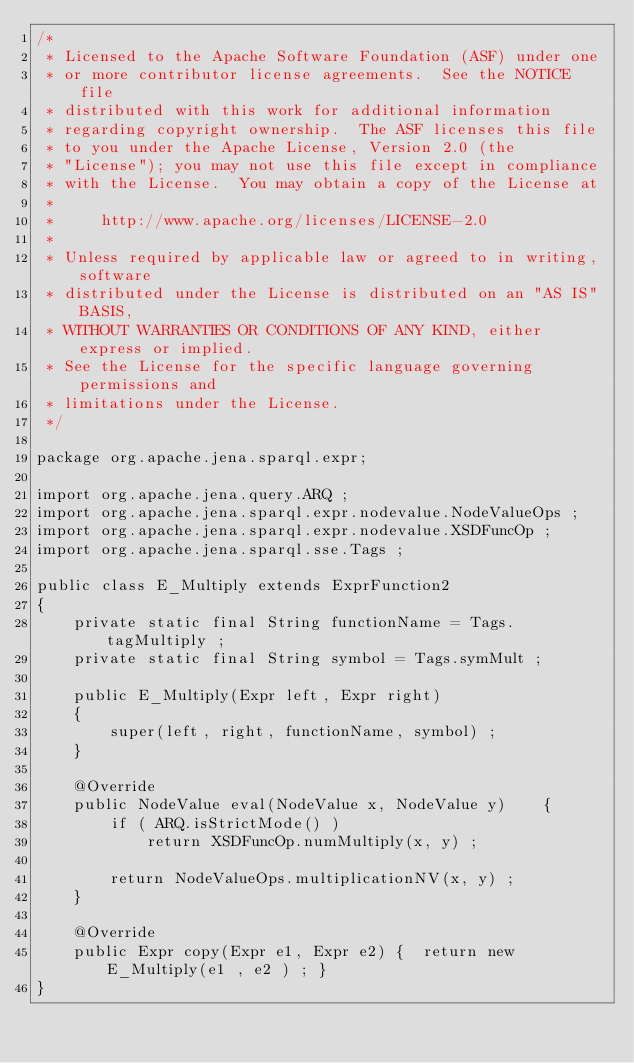<code> <loc_0><loc_0><loc_500><loc_500><_Java_>/*
 * Licensed to the Apache Software Foundation (ASF) under one
 * or more contributor license agreements.  See the NOTICE file
 * distributed with this work for additional information
 * regarding copyright ownership.  The ASF licenses this file
 * to you under the Apache License, Version 2.0 (the
 * "License"); you may not use this file except in compliance
 * with the License.  You may obtain a copy of the License at
 *
 *     http://www.apache.org/licenses/LICENSE-2.0
 *
 * Unless required by applicable law or agreed to in writing, software
 * distributed under the License is distributed on an "AS IS" BASIS,
 * WITHOUT WARRANTIES OR CONDITIONS OF ANY KIND, either express or implied.
 * See the License for the specific language governing permissions and
 * limitations under the License.
 */

package org.apache.jena.sparql.expr;

import org.apache.jena.query.ARQ ;
import org.apache.jena.sparql.expr.nodevalue.NodeValueOps ;
import org.apache.jena.sparql.expr.nodevalue.XSDFuncOp ;
import org.apache.jena.sparql.sse.Tags ;

public class E_Multiply extends ExprFunction2
{
    private static final String functionName = Tags.tagMultiply ;
    private static final String symbol = Tags.symMult ;
    
    public E_Multiply(Expr left, Expr right)
    {
        super(left, right, functionName, symbol) ;
    }
    
    @Override
    public NodeValue eval(NodeValue x, NodeValue y)    {
        if ( ARQ.isStrictMode() )
            return XSDFuncOp.numMultiply(x, y) ;

        return NodeValueOps.multiplicationNV(x, y) ;
    }
    
    @Override
    public Expr copy(Expr e1, Expr e2) {  return new E_Multiply(e1 , e2 ) ; }
}
</code> 